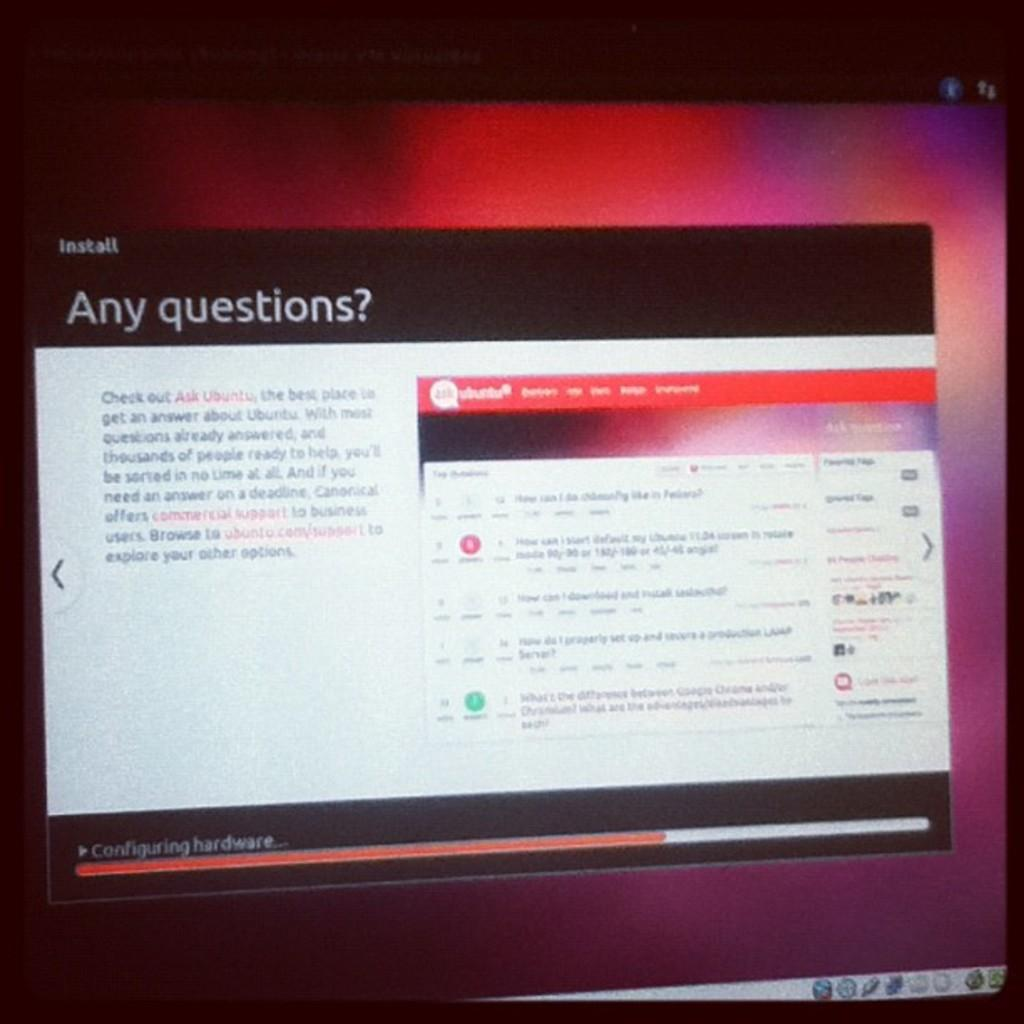<image>
Write a terse but informative summary of the picture. Computer screen asking if people had any questions. 